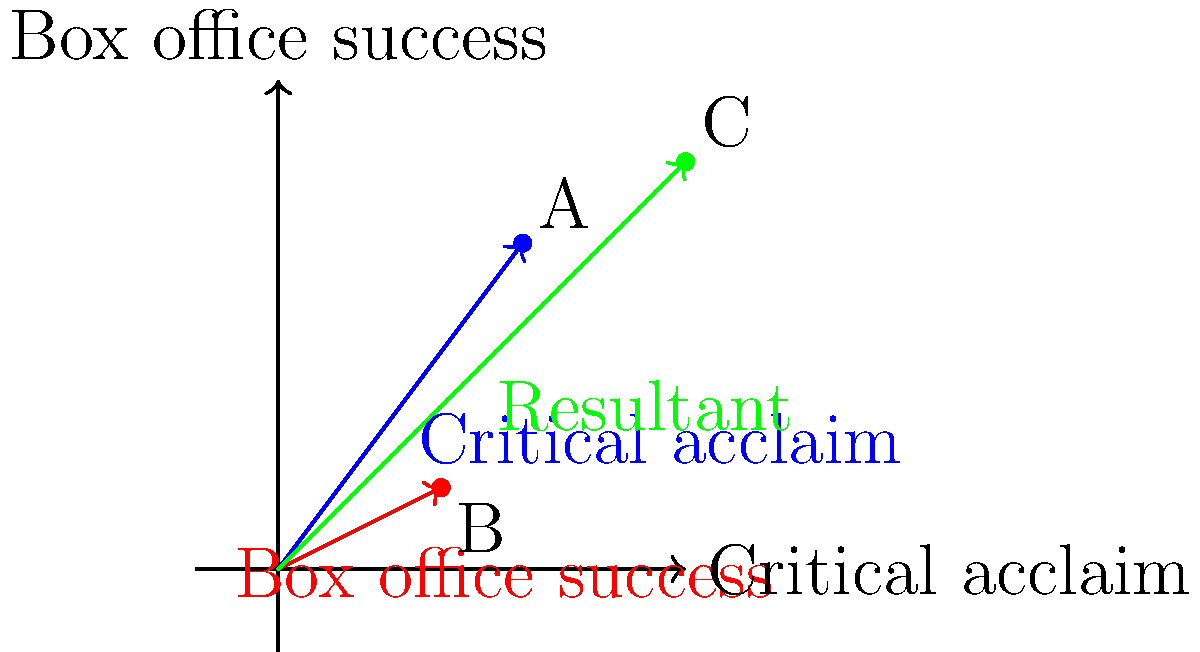In the graph above, vectors represent an emerging actor's critical acclaim (blue) and box office success (red) for their breakthrough role. The x-axis represents critical acclaim, and the y-axis represents box office success. If vector A (3, 4) represents critical acclaim and vector B (2, 1) represents box office success, what is the magnitude of the resultant vector C, which represents the actor's overall performance impact? To find the magnitude of the resultant vector C, we need to follow these steps:

1. Identify the components of vectors A and B:
   Vector A (critical acclaim): $(3, 4)$
   Vector B (box office success): $(2, 1)$

2. Calculate the sum of the vectors to get the resultant vector C:
   $C_x = A_x + B_x = 3 + 2 = 5$
   $C_y = A_y + B_y = 4 + 1 = 5$
   Resultant vector C: $(5, 5)$

3. Use the Pythagorean theorem to calculate the magnitude of vector C:
   $\text{Magnitude} = \sqrt{C_x^2 + C_y^2}$
   $\text{Magnitude} = \sqrt{5^2 + 5^2}$
   $\text{Magnitude} = \sqrt{50}$
   $\text{Magnitude} = 5\sqrt{2}$

4. Simplify the result:
   $5\sqrt{2} \approx 7.07$

Therefore, the magnitude of the resultant vector C, representing the actor's overall performance impact, is approximately 7.07 units.
Answer: $5\sqrt{2}$ or approximately 7.07 